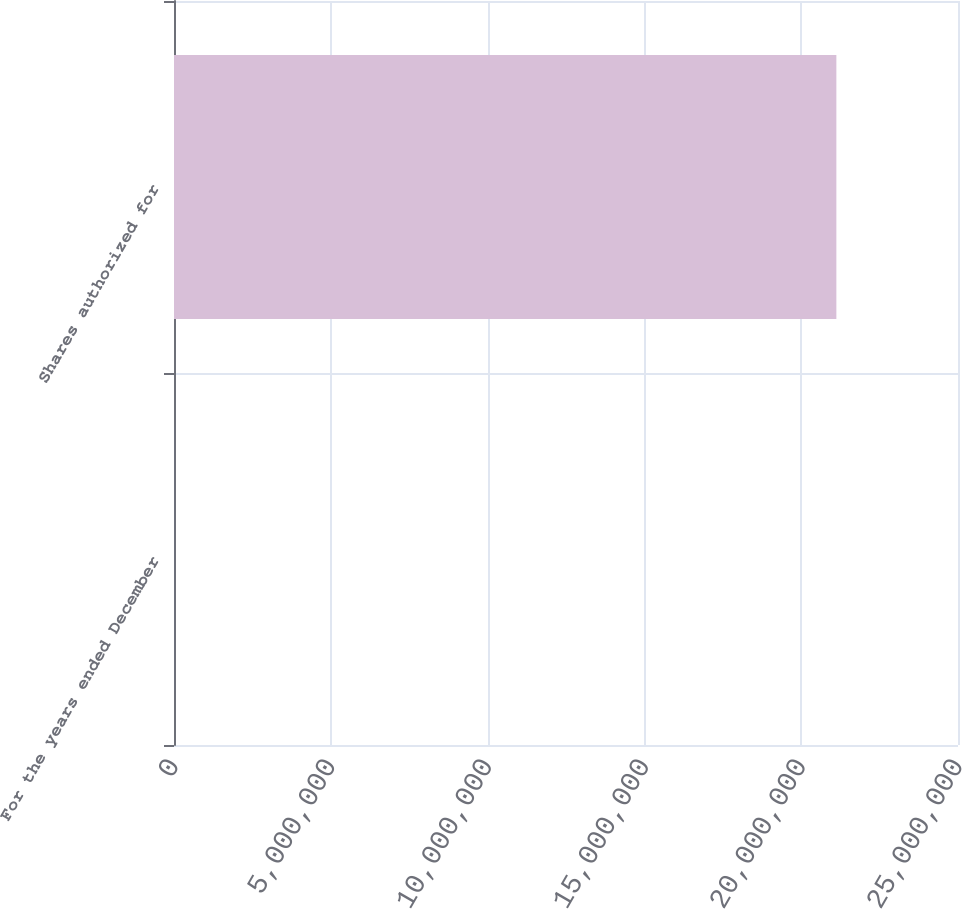<chart> <loc_0><loc_0><loc_500><loc_500><bar_chart><fcel>For the years ended December<fcel>Shares authorized for<nl><fcel>2008<fcel>2.11215e+07<nl></chart> 